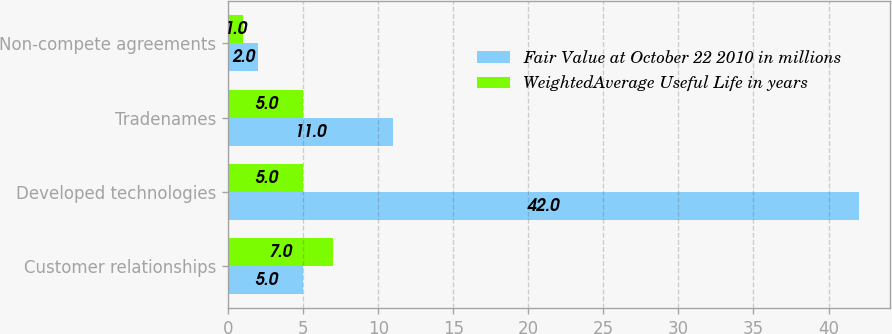<chart> <loc_0><loc_0><loc_500><loc_500><stacked_bar_chart><ecel><fcel>Customer relationships<fcel>Developed technologies<fcel>Tradenames<fcel>Non-compete agreements<nl><fcel>Fair Value at October 22 2010 in millions<fcel>5<fcel>42<fcel>11<fcel>2<nl><fcel>WeightedAverage Useful Life in years<fcel>7<fcel>5<fcel>5<fcel>1<nl></chart> 